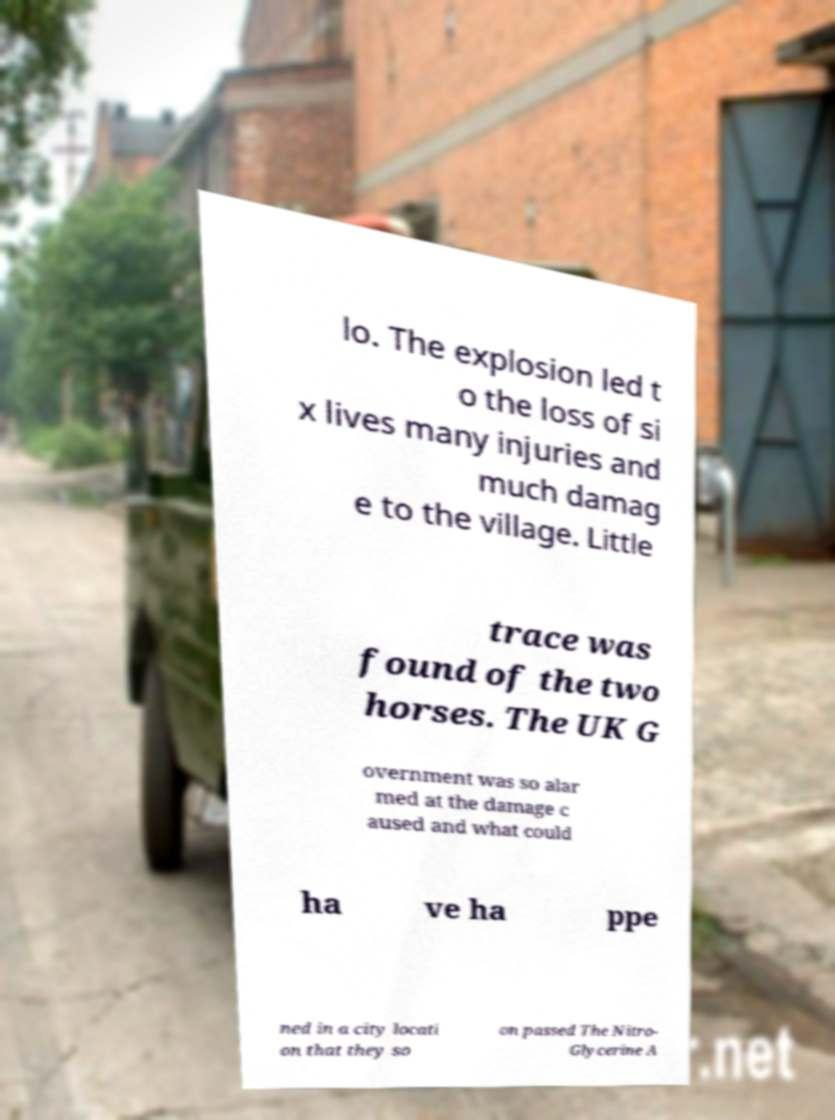Could you assist in decoding the text presented in this image and type it out clearly? lo. The explosion led t o the loss of si x lives many injuries and much damag e to the village. Little trace was found of the two horses. The UK G overnment was so alar med at the damage c aused and what could ha ve ha ppe ned in a city locati on that they so on passed The Nitro- Glycerine A 